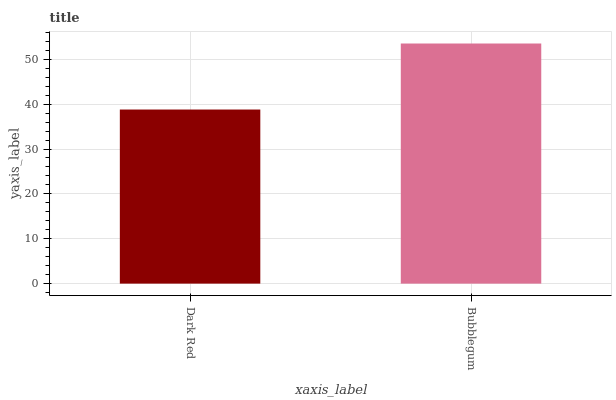Is Dark Red the minimum?
Answer yes or no. Yes. Is Bubblegum the maximum?
Answer yes or no. Yes. Is Bubblegum the minimum?
Answer yes or no. No. Is Bubblegum greater than Dark Red?
Answer yes or no. Yes. Is Dark Red less than Bubblegum?
Answer yes or no. Yes. Is Dark Red greater than Bubblegum?
Answer yes or no. No. Is Bubblegum less than Dark Red?
Answer yes or no. No. Is Bubblegum the high median?
Answer yes or no. Yes. Is Dark Red the low median?
Answer yes or no. Yes. Is Dark Red the high median?
Answer yes or no. No. Is Bubblegum the low median?
Answer yes or no. No. 